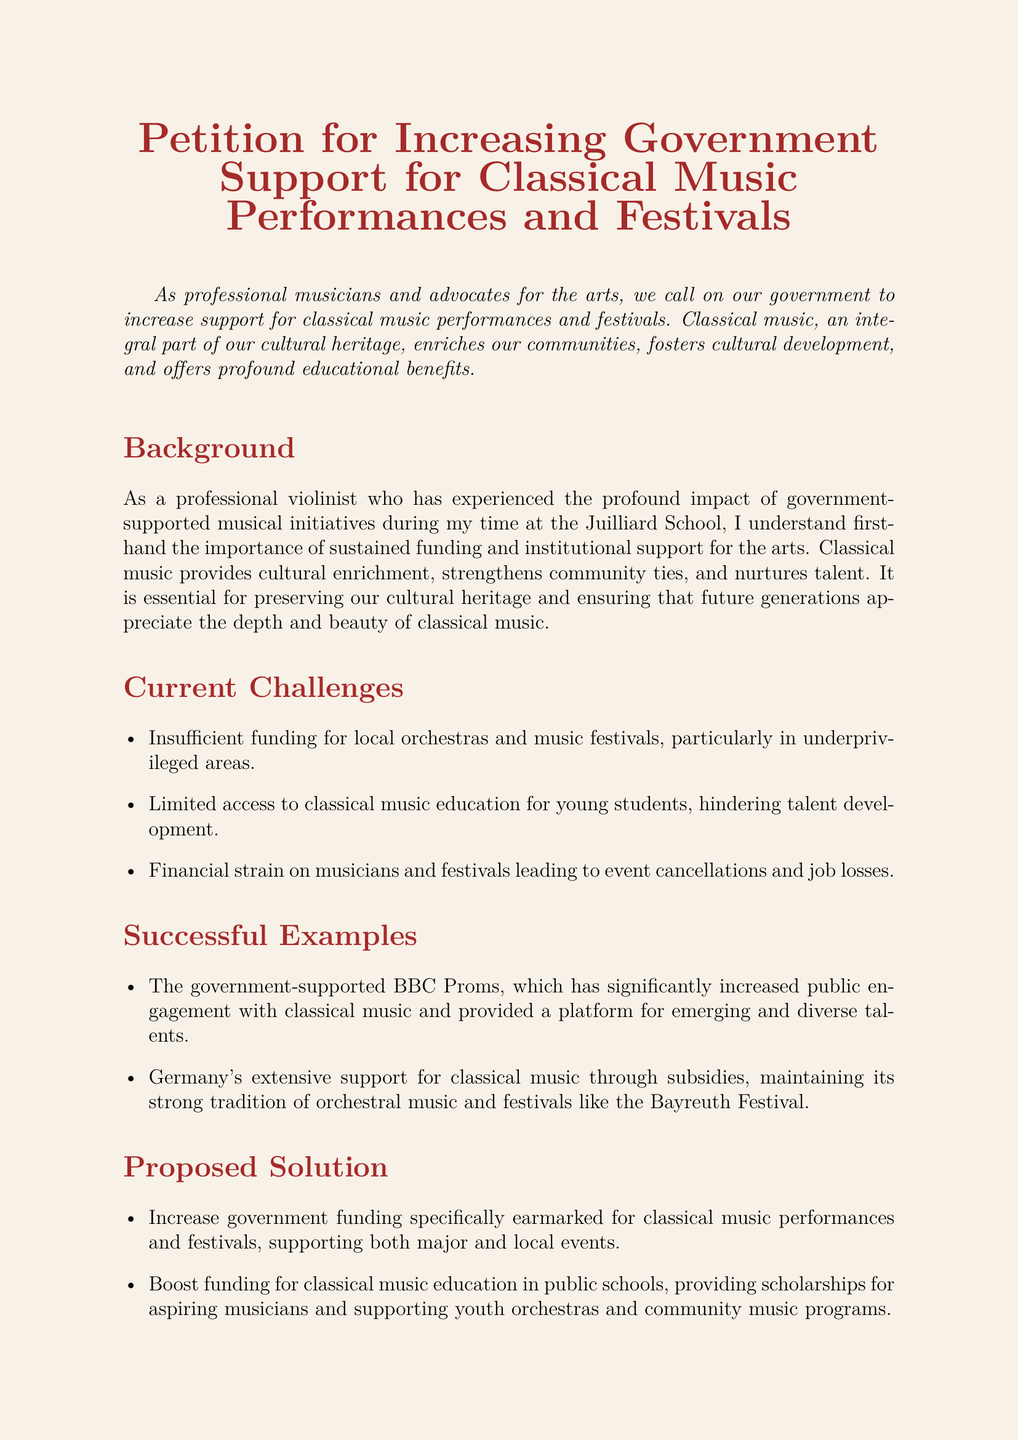What is the main purpose of the petition? The petition aims to call on the government to increase support for classical music performances and festivals.
Answer: Increase support for classical music performances and festivals What are the current challenges facing classical music? The document lists three specific challenges faced by classical music, including funding issues and access to education.
Answer: Insufficient funding, limited access to education, financial strain How does the document describe the impact of classical music on communities? The petition states that classical music enriches communities and fosters cultural development.
Answer: Enriches communities and fosters cultural development What successful example of government support for classical music is mentioned? The petition mentions the BBC Proms as a successful example of government-supported classical music initiatives.
Answer: BBC Proms What is the proposed solution regarding funding for public schools? The document proposes boosting funding for classical music education in public schools.
Answer: Boost funding for classical music education in public schools What kind of support is proposed for young artists? The petition suggests establishing grants and financial aid programs for young artists and ensembles.
Answer: Grants and financial aid programs What is the call to action at the end of the petition? The conclusion encourages individuals to sign the petition and advocate for stronger governmental support for the arts.
Answer: Sign this petition and advocate for stronger governmental support What is the significance of government-supported initiatives, according to the document? The document highlights that government-supported initiatives help preserve cultural heritage and ensure appreciation of classical music.
Answer: Preserve cultural heritage and appreciation of classical music 